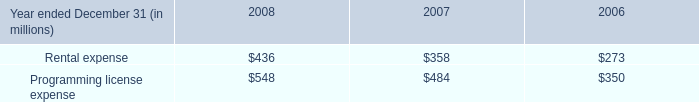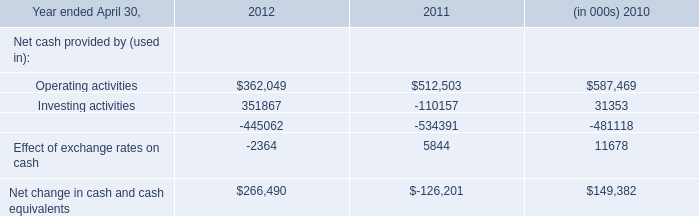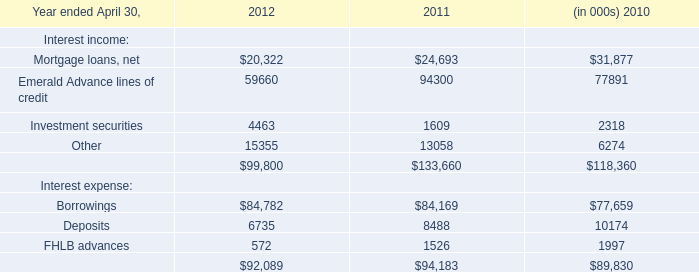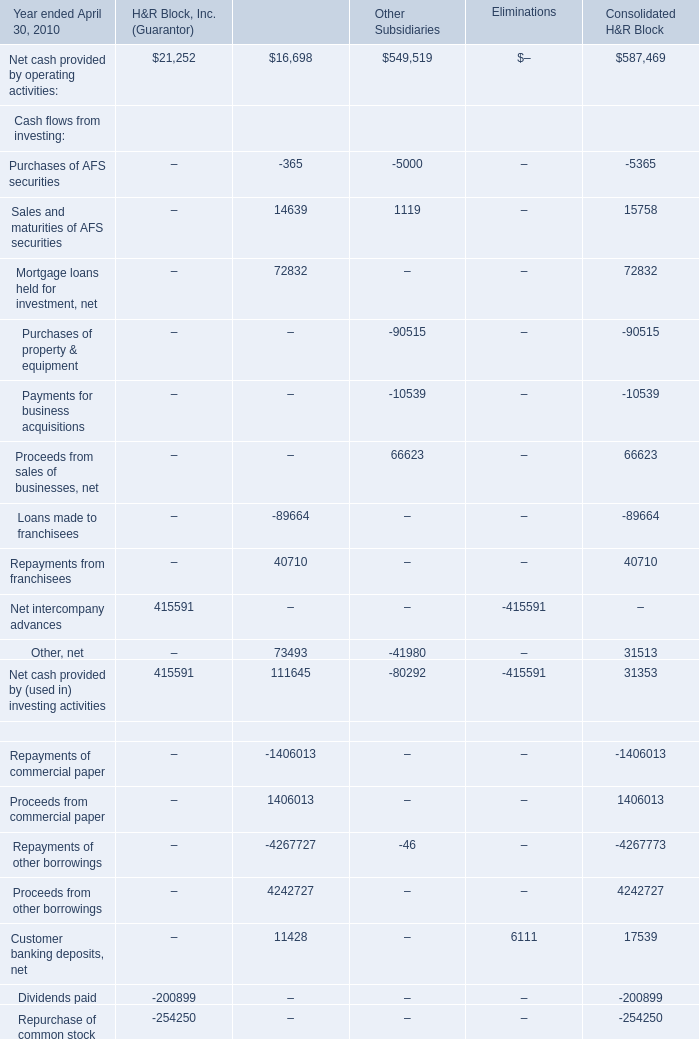Does the value of Net cash provided by operating activities: in Block Financial (Issuer)greater than that in H&R Block, Inc. (Guarantor 
Answer: no. 